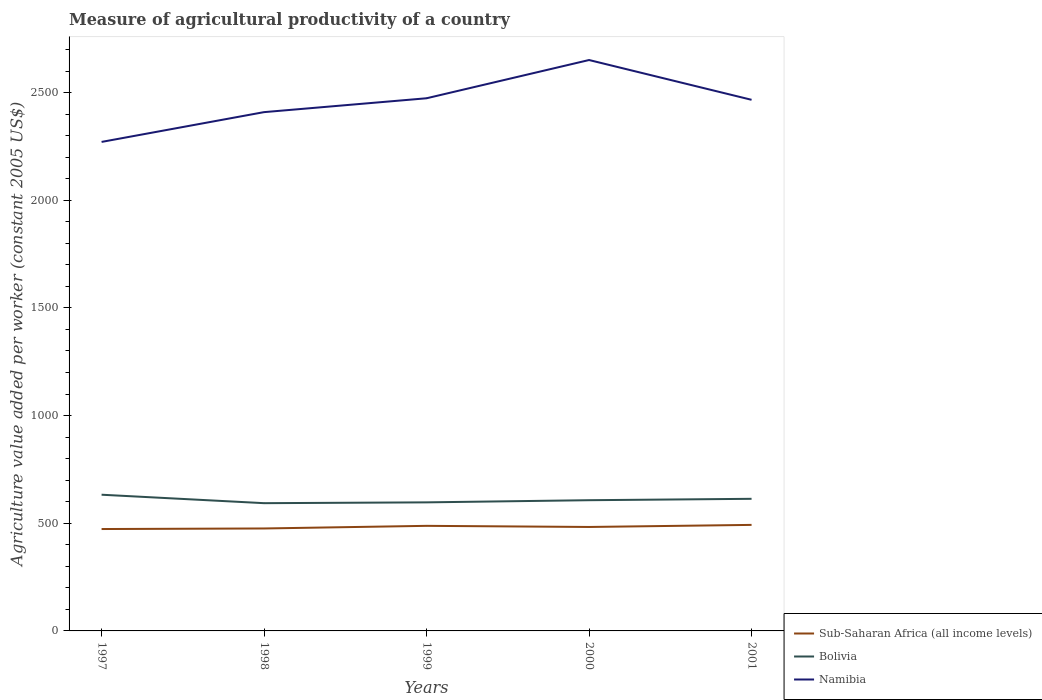How many different coloured lines are there?
Keep it short and to the point. 3. Does the line corresponding to Namibia intersect with the line corresponding to Bolivia?
Offer a terse response. No. Is the number of lines equal to the number of legend labels?
Ensure brevity in your answer.  Yes. Across all years, what is the maximum measure of agricultural productivity in Sub-Saharan Africa (all income levels)?
Offer a very short reply. 473.21. In which year was the measure of agricultural productivity in Namibia maximum?
Give a very brief answer. 1997. What is the total measure of agricultural productivity in Sub-Saharan Africa (all income levels) in the graph?
Provide a succinct answer. -9.66. What is the difference between the highest and the second highest measure of agricultural productivity in Namibia?
Your answer should be compact. 380.31. What is the difference between the highest and the lowest measure of agricultural productivity in Namibia?
Offer a very short reply. 3. Is the measure of agricultural productivity in Bolivia strictly greater than the measure of agricultural productivity in Namibia over the years?
Make the answer very short. Yes. How many years are there in the graph?
Keep it short and to the point. 5. What is the difference between two consecutive major ticks on the Y-axis?
Provide a short and direct response. 500. Are the values on the major ticks of Y-axis written in scientific E-notation?
Offer a very short reply. No. Does the graph contain grids?
Provide a short and direct response. No. Where does the legend appear in the graph?
Give a very brief answer. Bottom right. How many legend labels are there?
Ensure brevity in your answer.  3. How are the legend labels stacked?
Your response must be concise. Vertical. What is the title of the graph?
Provide a succinct answer. Measure of agricultural productivity of a country. What is the label or title of the Y-axis?
Your answer should be very brief. Agriculture value added per worker (constant 2005 US$). What is the Agriculture value added per worker (constant 2005 US$) of Sub-Saharan Africa (all income levels) in 1997?
Provide a short and direct response. 473.21. What is the Agriculture value added per worker (constant 2005 US$) of Bolivia in 1997?
Offer a very short reply. 632.54. What is the Agriculture value added per worker (constant 2005 US$) of Namibia in 1997?
Provide a short and direct response. 2271. What is the Agriculture value added per worker (constant 2005 US$) of Sub-Saharan Africa (all income levels) in 1998?
Keep it short and to the point. 475.82. What is the Agriculture value added per worker (constant 2005 US$) in Bolivia in 1998?
Ensure brevity in your answer.  593.28. What is the Agriculture value added per worker (constant 2005 US$) of Namibia in 1998?
Your answer should be compact. 2409.33. What is the Agriculture value added per worker (constant 2005 US$) of Sub-Saharan Africa (all income levels) in 1999?
Keep it short and to the point. 487.99. What is the Agriculture value added per worker (constant 2005 US$) of Bolivia in 1999?
Provide a succinct answer. 597.05. What is the Agriculture value added per worker (constant 2005 US$) of Namibia in 1999?
Give a very brief answer. 2473.71. What is the Agriculture value added per worker (constant 2005 US$) of Sub-Saharan Africa (all income levels) in 2000?
Your answer should be very brief. 482.76. What is the Agriculture value added per worker (constant 2005 US$) of Bolivia in 2000?
Your response must be concise. 607.1. What is the Agriculture value added per worker (constant 2005 US$) in Namibia in 2000?
Provide a succinct answer. 2651.31. What is the Agriculture value added per worker (constant 2005 US$) of Sub-Saharan Africa (all income levels) in 2001?
Provide a succinct answer. 492.42. What is the Agriculture value added per worker (constant 2005 US$) in Bolivia in 2001?
Provide a succinct answer. 613.56. What is the Agriculture value added per worker (constant 2005 US$) of Namibia in 2001?
Keep it short and to the point. 2466.51. Across all years, what is the maximum Agriculture value added per worker (constant 2005 US$) of Sub-Saharan Africa (all income levels)?
Offer a terse response. 492.42. Across all years, what is the maximum Agriculture value added per worker (constant 2005 US$) in Bolivia?
Provide a succinct answer. 632.54. Across all years, what is the maximum Agriculture value added per worker (constant 2005 US$) in Namibia?
Keep it short and to the point. 2651.31. Across all years, what is the minimum Agriculture value added per worker (constant 2005 US$) of Sub-Saharan Africa (all income levels)?
Your response must be concise. 473.21. Across all years, what is the minimum Agriculture value added per worker (constant 2005 US$) in Bolivia?
Offer a terse response. 593.28. Across all years, what is the minimum Agriculture value added per worker (constant 2005 US$) of Namibia?
Offer a terse response. 2271. What is the total Agriculture value added per worker (constant 2005 US$) in Sub-Saharan Africa (all income levels) in the graph?
Make the answer very short. 2412.2. What is the total Agriculture value added per worker (constant 2005 US$) of Bolivia in the graph?
Your answer should be compact. 3043.53. What is the total Agriculture value added per worker (constant 2005 US$) of Namibia in the graph?
Offer a very short reply. 1.23e+04. What is the difference between the Agriculture value added per worker (constant 2005 US$) in Sub-Saharan Africa (all income levels) in 1997 and that in 1998?
Your response must be concise. -2.61. What is the difference between the Agriculture value added per worker (constant 2005 US$) of Bolivia in 1997 and that in 1998?
Offer a very short reply. 39.26. What is the difference between the Agriculture value added per worker (constant 2005 US$) of Namibia in 1997 and that in 1998?
Your answer should be compact. -138.32. What is the difference between the Agriculture value added per worker (constant 2005 US$) of Sub-Saharan Africa (all income levels) in 1997 and that in 1999?
Ensure brevity in your answer.  -14.77. What is the difference between the Agriculture value added per worker (constant 2005 US$) of Bolivia in 1997 and that in 1999?
Offer a very short reply. 35.5. What is the difference between the Agriculture value added per worker (constant 2005 US$) of Namibia in 1997 and that in 1999?
Offer a terse response. -202.7. What is the difference between the Agriculture value added per worker (constant 2005 US$) of Sub-Saharan Africa (all income levels) in 1997 and that in 2000?
Your answer should be compact. -9.55. What is the difference between the Agriculture value added per worker (constant 2005 US$) in Bolivia in 1997 and that in 2000?
Offer a terse response. 25.44. What is the difference between the Agriculture value added per worker (constant 2005 US$) in Namibia in 1997 and that in 2000?
Give a very brief answer. -380.31. What is the difference between the Agriculture value added per worker (constant 2005 US$) in Sub-Saharan Africa (all income levels) in 1997 and that in 2001?
Give a very brief answer. -19.21. What is the difference between the Agriculture value added per worker (constant 2005 US$) in Bolivia in 1997 and that in 2001?
Ensure brevity in your answer.  18.98. What is the difference between the Agriculture value added per worker (constant 2005 US$) in Namibia in 1997 and that in 2001?
Give a very brief answer. -195.51. What is the difference between the Agriculture value added per worker (constant 2005 US$) in Sub-Saharan Africa (all income levels) in 1998 and that in 1999?
Make the answer very short. -12.16. What is the difference between the Agriculture value added per worker (constant 2005 US$) of Bolivia in 1998 and that in 1999?
Your answer should be compact. -3.77. What is the difference between the Agriculture value added per worker (constant 2005 US$) of Namibia in 1998 and that in 1999?
Ensure brevity in your answer.  -64.38. What is the difference between the Agriculture value added per worker (constant 2005 US$) in Sub-Saharan Africa (all income levels) in 1998 and that in 2000?
Your response must be concise. -6.94. What is the difference between the Agriculture value added per worker (constant 2005 US$) in Bolivia in 1998 and that in 2000?
Your response must be concise. -13.82. What is the difference between the Agriculture value added per worker (constant 2005 US$) in Namibia in 1998 and that in 2000?
Your answer should be compact. -241.98. What is the difference between the Agriculture value added per worker (constant 2005 US$) of Sub-Saharan Africa (all income levels) in 1998 and that in 2001?
Ensure brevity in your answer.  -16.6. What is the difference between the Agriculture value added per worker (constant 2005 US$) of Bolivia in 1998 and that in 2001?
Your response must be concise. -20.28. What is the difference between the Agriculture value added per worker (constant 2005 US$) of Namibia in 1998 and that in 2001?
Your answer should be very brief. -57.18. What is the difference between the Agriculture value added per worker (constant 2005 US$) in Sub-Saharan Africa (all income levels) in 1999 and that in 2000?
Offer a very short reply. 5.22. What is the difference between the Agriculture value added per worker (constant 2005 US$) of Bolivia in 1999 and that in 2000?
Ensure brevity in your answer.  -10.06. What is the difference between the Agriculture value added per worker (constant 2005 US$) of Namibia in 1999 and that in 2000?
Your answer should be compact. -177.6. What is the difference between the Agriculture value added per worker (constant 2005 US$) in Sub-Saharan Africa (all income levels) in 1999 and that in 2001?
Your answer should be compact. -4.43. What is the difference between the Agriculture value added per worker (constant 2005 US$) in Bolivia in 1999 and that in 2001?
Your response must be concise. -16.52. What is the difference between the Agriculture value added per worker (constant 2005 US$) in Namibia in 1999 and that in 2001?
Give a very brief answer. 7.19. What is the difference between the Agriculture value added per worker (constant 2005 US$) in Sub-Saharan Africa (all income levels) in 2000 and that in 2001?
Offer a terse response. -9.66. What is the difference between the Agriculture value added per worker (constant 2005 US$) of Bolivia in 2000 and that in 2001?
Keep it short and to the point. -6.46. What is the difference between the Agriculture value added per worker (constant 2005 US$) of Namibia in 2000 and that in 2001?
Your answer should be compact. 184.8. What is the difference between the Agriculture value added per worker (constant 2005 US$) in Sub-Saharan Africa (all income levels) in 1997 and the Agriculture value added per worker (constant 2005 US$) in Bolivia in 1998?
Give a very brief answer. -120.07. What is the difference between the Agriculture value added per worker (constant 2005 US$) in Sub-Saharan Africa (all income levels) in 1997 and the Agriculture value added per worker (constant 2005 US$) in Namibia in 1998?
Provide a short and direct response. -1936.12. What is the difference between the Agriculture value added per worker (constant 2005 US$) of Bolivia in 1997 and the Agriculture value added per worker (constant 2005 US$) of Namibia in 1998?
Offer a terse response. -1776.79. What is the difference between the Agriculture value added per worker (constant 2005 US$) in Sub-Saharan Africa (all income levels) in 1997 and the Agriculture value added per worker (constant 2005 US$) in Bolivia in 1999?
Give a very brief answer. -123.83. What is the difference between the Agriculture value added per worker (constant 2005 US$) of Sub-Saharan Africa (all income levels) in 1997 and the Agriculture value added per worker (constant 2005 US$) of Namibia in 1999?
Give a very brief answer. -2000.49. What is the difference between the Agriculture value added per worker (constant 2005 US$) in Bolivia in 1997 and the Agriculture value added per worker (constant 2005 US$) in Namibia in 1999?
Your answer should be compact. -1841.16. What is the difference between the Agriculture value added per worker (constant 2005 US$) in Sub-Saharan Africa (all income levels) in 1997 and the Agriculture value added per worker (constant 2005 US$) in Bolivia in 2000?
Your answer should be very brief. -133.89. What is the difference between the Agriculture value added per worker (constant 2005 US$) in Sub-Saharan Africa (all income levels) in 1997 and the Agriculture value added per worker (constant 2005 US$) in Namibia in 2000?
Keep it short and to the point. -2178.1. What is the difference between the Agriculture value added per worker (constant 2005 US$) in Bolivia in 1997 and the Agriculture value added per worker (constant 2005 US$) in Namibia in 2000?
Provide a succinct answer. -2018.77. What is the difference between the Agriculture value added per worker (constant 2005 US$) in Sub-Saharan Africa (all income levels) in 1997 and the Agriculture value added per worker (constant 2005 US$) in Bolivia in 2001?
Give a very brief answer. -140.35. What is the difference between the Agriculture value added per worker (constant 2005 US$) of Sub-Saharan Africa (all income levels) in 1997 and the Agriculture value added per worker (constant 2005 US$) of Namibia in 2001?
Your answer should be very brief. -1993.3. What is the difference between the Agriculture value added per worker (constant 2005 US$) in Bolivia in 1997 and the Agriculture value added per worker (constant 2005 US$) in Namibia in 2001?
Make the answer very short. -1833.97. What is the difference between the Agriculture value added per worker (constant 2005 US$) in Sub-Saharan Africa (all income levels) in 1998 and the Agriculture value added per worker (constant 2005 US$) in Bolivia in 1999?
Provide a succinct answer. -121.22. What is the difference between the Agriculture value added per worker (constant 2005 US$) of Sub-Saharan Africa (all income levels) in 1998 and the Agriculture value added per worker (constant 2005 US$) of Namibia in 1999?
Your answer should be very brief. -1997.88. What is the difference between the Agriculture value added per worker (constant 2005 US$) in Bolivia in 1998 and the Agriculture value added per worker (constant 2005 US$) in Namibia in 1999?
Give a very brief answer. -1880.43. What is the difference between the Agriculture value added per worker (constant 2005 US$) of Sub-Saharan Africa (all income levels) in 1998 and the Agriculture value added per worker (constant 2005 US$) of Bolivia in 2000?
Keep it short and to the point. -131.28. What is the difference between the Agriculture value added per worker (constant 2005 US$) in Sub-Saharan Africa (all income levels) in 1998 and the Agriculture value added per worker (constant 2005 US$) in Namibia in 2000?
Give a very brief answer. -2175.49. What is the difference between the Agriculture value added per worker (constant 2005 US$) of Bolivia in 1998 and the Agriculture value added per worker (constant 2005 US$) of Namibia in 2000?
Keep it short and to the point. -2058.03. What is the difference between the Agriculture value added per worker (constant 2005 US$) in Sub-Saharan Africa (all income levels) in 1998 and the Agriculture value added per worker (constant 2005 US$) in Bolivia in 2001?
Offer a very short reply. -137.74. What is the difference between the Agriculture value added per worker (constant 2005 US$) in Sub-Saharan Africa (all income levels) in 1998 and the Agriculture value added per worker (constant 2005 US$) in Namibia in 2001?
Ensure brevity in your answer.  -1990.69. What is the difference between the Agriculture value added per worker (constant 2005 US$) of Bolivia in 1998 and the Agriculture value added per worker (constant 2005 US$) of Namibia in 2001?
Give a very brief answer. -1873.23. What is the difference between the Agriculture value added per worker (constant 2005 US$) of Sub-Saharan Africa (all income levels) in 1999 and the Agriculture value added per worker (constant 2005 US$) of Bolivia in 2000?
Ensure brevity in your answer.  -119.12. What is the difference between the Agriculture value added per worker (constant 2005 US$) in Sub-Saharan Africa (all income levels) in 1999 and the Agriculture value added per worker (constant 2005 US$) in Namibia in 2000?
Provide a short and direct response. -2163.32. What is the difference between the Agriculture value added per worker (constant 2005 US$) in Bolivia in 1999 and the Agriculture value added per worker (constant 2005 US$) in Namibia in 2000?
Provide a short and direct response. -2054.26. What is the difference between the Agriculture value added per worker (constant 2005 US$) in Sub-Saharan Africa (all income levels) in 1999 and the Agriculture value added per worker (constant 2005 US$) in Bolivia in 2001?
Your answer should be very brief. -125.58. What is the difference between the Agriculture value added per worker (constant 2005 US$) of Sub-Saharan Africa (all income levels) in 1999 and the Agriculture value added per worker (constant 2005 US$) of Namibia in 2001?
Ensure brevity in your answer.  -1978.53. What is the difference between the Agriculture value added per worker (constant 2005 US$) in Bolivia in 1999 and the Agriculture value added per worker (constant 2005 US$) in Namibia in 2001?
Your answer should be very brief. -1869.47. What is the difference between the Agriculture value added per worker (constant 2005 US$) in Sub-Saharan Africa (all income levels) in 2000 and the Agriculture value added per worker (constant 2005 US$) in Bolivia in 2001?
Keep it short and to the point. -130.8. What is the difference between the Agriculture value added per worker (constant 2005 US$) of Sub-Saharan Africa (all income levels) in 2000 and the Agriculture value added per worker (constant 2005 US$) of Namibia in 2001?
Make the answer very short. -1983.75. What is the difference between the Agriculture value added per worker (constant 2005 US$) in Bolivia in 2000 and the Agriculture value added per worker (constant 2005 US$) in Namibia in 2001?
Offer a terse response. -1859.41. What is the average Agriculture value added per worker (constant 2005 US$) in Sub-Saharan Africa (all income levels) per year?
Your answer should be compact. 482.44. What is the average Agriculture value added per worker (constant 2005 US$) of Bolivia per year?
Give a very brief answer. 608.71. What is the average Agriculture value added per worker (constant 2005 US$) of Namibia per year?
Your answer should be compact. 2454.37. In the year 1997, what is the difference between the Agriculture value added per worker (constant 2005 US$) of Sub-Saharan Africa (all income levels) and Agriculture value added per worker (constant 2005 US$) of Bolivia?
Your response must be concise. -159.33. In the year 1997, what is the difference between the Agriculture value added per worker (constant 2005 US$) of Sub-Saharan Africa (all income levels) and Agriculture value added per worker (constant 2005 US$) of Namibia?
Your answer should be compact. -1797.79. In the year 1997, what is the difference between the Agriculture value added per worker (constant 2005 US$) of Bolivia and Agriculture value added per worker (constant 2005 US$) of Namibia?
Make the answer very short. -1638.46. In the year 1998, what is the difference between the Agriculture value added per worker (constant 2005 US$) in Sub-Saharan Africa (all income levels) and Agriculture value added per worker (constant 2005 US$) in Bolivia?
Your answer should be compact. -117.46. In the year 1998, what is the difference between the Agriculture value added per worker (constant 2005 US$) of Sub-Saharan Africa (all income levels) and Agriculture value added per worker (constant 2005 US$) of Namibia?
Give a very brief answer. -1933.5. In the year 1998, what is the difference between the Agriculture value added per worker (constant 2005 US$) in Bolivia and Agriculture value added per worker (constant 2005 US$) in Namibia?
Give a very brief answer. -1816.05. In the year 1999, what is the difference between the Agriculture value added per worker (constant 2005 US$) of Sub-Saharan Africa (all income levels) and Agriculture value added per worker (constant 2005 US$) of Bolivia?
Your answer should be very brief. -109.06. In the year 1999, what is the difference between the Agriculture value added per worker (constant 2005 US$) of Sub-Saharan Africa (all income levels) and Agriculture value added per worker (constant 2005 US$) of Namibia?
Give a very brief answer. -1985.72. In the year 1999, what is the difference between the Agriculture value added per worker (constant 2005 US$) of Bolivia and Agriculture value added per worker (constant 2005 US$) of Namibia?
Give a very brief answer. -1876.66. In the year 2000, what is the difference between the Agriculture value added per worker (constant 2005 US$) in Sub-Saharan Africa (all income levels) and Agriculture value added per worker (constant 2005 US$) in Bolivia?
Make the answer very short. -124.34. In the year 2000, what is the difference between the Agriculture value added per worker (constant 2005 US$) in Sub-Saharan Africa (all income levels) and Agriculture value added per worker (constant 2005 US$) in Namibia?
Give a very brief answer. -2168.55. In the year 2000, what is the difference between the Agriculture value added per worker (constant 2005 US$) of Bolivia and Agriculture value added per worker (constant 2005 US$) of Namibia?
Make the answer very short. -2044.21. In the year 2001, what is the difference between the Agriculture value added per worker (constant 2005 US$) in Sub-Saharan Africa (all income levels) and Agriculture value added per worker (constant 2005 US$) in Bolivia?
Your answer should be very brief. -121.14. In the year 2001, what is the difference between the Agriculture value added per worker (constant 2005 US$) of Sub-Saharan Africa (all income levels) and Agriculture value added per worker (constant 2005 US$) of Namibia?
Offer a very short reply. -1974.09. In the year 2001, what is the difference between the Agriculture value added per worker (constant 2005 US$) of Bolivia and Agriculture value added per worker (constant 2005 US$) of Namibia?
Your response must be concise. -1852.95. What is the ratio of the Agriculture value added per worker (constant 2005 US$) of Bolivia in 1997 to that in 1998?
Your answer should be compact. 1.07. What is the ratio of the Agriculture value added per worker (constant 2005 US$) in Namibia in 1997 to that in 1998?
Provide a short and direct response. 0.94. What is the ratio of the Agriculture value added per worker (constant 2005 US$) in Sub-Saharan Africa (all income levels) in 1997 to that in 1999?
Your response must be concise. 0.97. What is the ratio of the Agriculture value added per worker (constant 2005 US$) in Bolivia in 1997 to that in 1999?
Your answer should be very brief. 1.06. What is the ratio of the Agriculture value added per worker (constant 2005 US$) in Namibia in 1997 to that in 1999?
Make the answer very short. 0.92. What is the ratio of the Agriculture value added per worker (constant 2005 US$) of Sub-Saharan Africa (all income levels) in 1997 to that in 2000?
Ensure brevity in your answer.  0.98. What is the ratio of the Agriculture value added per worker (constant 2005 US$) of Bolivia in 1997 to that in 2000?
Provide a succinct answer. 1.04. What is the ratio of the Agriculture value added per worker (constant 2005 US$) in Namibia in 1997 to that in 2000?
Provide a succinct answer. 0.86. What is the ratio of the Agriculture value added per worker (constant 2005 US$) in Bolivia in 1997 to that in 2001?
Offer a very short reply. 1.03. What is the ratio of the Agriculture value added per worker (constant 2005 US$) of Namibia in 1997 to that in 2001?
Your response must be concise. 0.92. What is the ratio of the Agriculture value added per worker (constant 2005 US$) in Sub-Saharan Africa (all income levels) in 1998 to that in 1999?
Your answer should be compact. 0.98. What is the ratio of the Agriculture value added per worker (constant 2005 US$) of Bolivia in 1998 to that in 1999?
Offer a very short reply. 0.99. What is the ratio of the Agriculture value added per worker (constant 2005 US$) of Namibia in 1998 to that in 1999?
Ensure brevity in your answer.  0.97. What is the ratio of the Agriculture value added per worker (constant 2005 US$) in Sub-Saharan Africa (all income levels) in 1998 to that in 2000?
Offer a very short reply. 0.99. What is the ratio of the Agriculture value added per worker (constant 2005 US$) in Bolivia in 1998 to that in 2000?
Your response must be concise. 0.98. What is the ratio of the Agriculture value added per worker (constant 2005 US$) of Namibia in 1998 to that in 2000?
Ensure brevity in your answer.  0.91. What is the ratio of the Agriculture value added per worker (constant 2005 US$) of Sub-Saharan Africa (all income levels) in 1998 to that in 2001?
Offer a very short reply. 0.97. What is the ratio of the Agriculture value added per worker (constant 2005 US$) of Bolivia in 1998 to that in 2001?
Your answer should be compact. 0.97. What is the ratio of the Agriculture value added per worker (constant 2005 US$) of Namibia in 1998 to that in 2001?
Make the answer very short. 0.98. What is the ratio of the Agriculture value added per worker (constant 2005 US$) of Sub-Saharan Africa (all income levels) in 1999 to that in 2000?
Offer a very short reply. 1.01. What is the ratio of the Agriculture value added per worker (constant 2005 US$) of Bolivia in 1999 to that in 2000?
Keep it short and to the point. 0.98. What is the ratio of the Agriculture value added per worker (constant 2005 US$) in Namibia in 1999 to that in 2000?
Provide a succinct answer. 0.93. What is the ratio of the Agriculture value added per worker (constant 2005 US$) of Bolivia in 1999 to that in 2001?
Ensure brevity in your answer.  0.97. What is the ratio of the Agriculture value added per worker (constant 2005 US$) of Sub-Saharan Africa (all income levels) in 2000 to that in 2001?
Make the answer very short. 0.98. What is the ratio of the Agriculture value added per worker (constant 2005 US$) in Namibia in 2000 to that in 2001?
Ensure brevity in your answer.  1.07. What is the difference between the highest and the second highest Agriculture value added per worker (constant 2005 US$) in Sub-Saharan Africa (all income levels)?
Your response must be concise. 4.43. What is the difference between the highest and the second highest Agriculture value added per worker (constant 2005 US$) of Bolivia?
Provide a short and direct response. 18.98. What is the difference between the highest and the second highest Agriculture value added per worker (constant 2005 US$) in Namibia?
Offer a terse response. 177.6. What is the difference between the highest and the lowest Agriculture value added per worker (constant 2005 US$) in Sub-Saharan Africa (all income levels)?
Your answer should be very brief. 19.21. What is the difference between the highest and the lowest Agriculture value added per worker (constant 2005 US$) of Bolivia?
Your answer should be very brief. 39.26. What is the difference between the highest and the lowest Agriculture value added per worker (constant 2005 US$) in Namibia?
Keep it short and to the point. 380.31. 